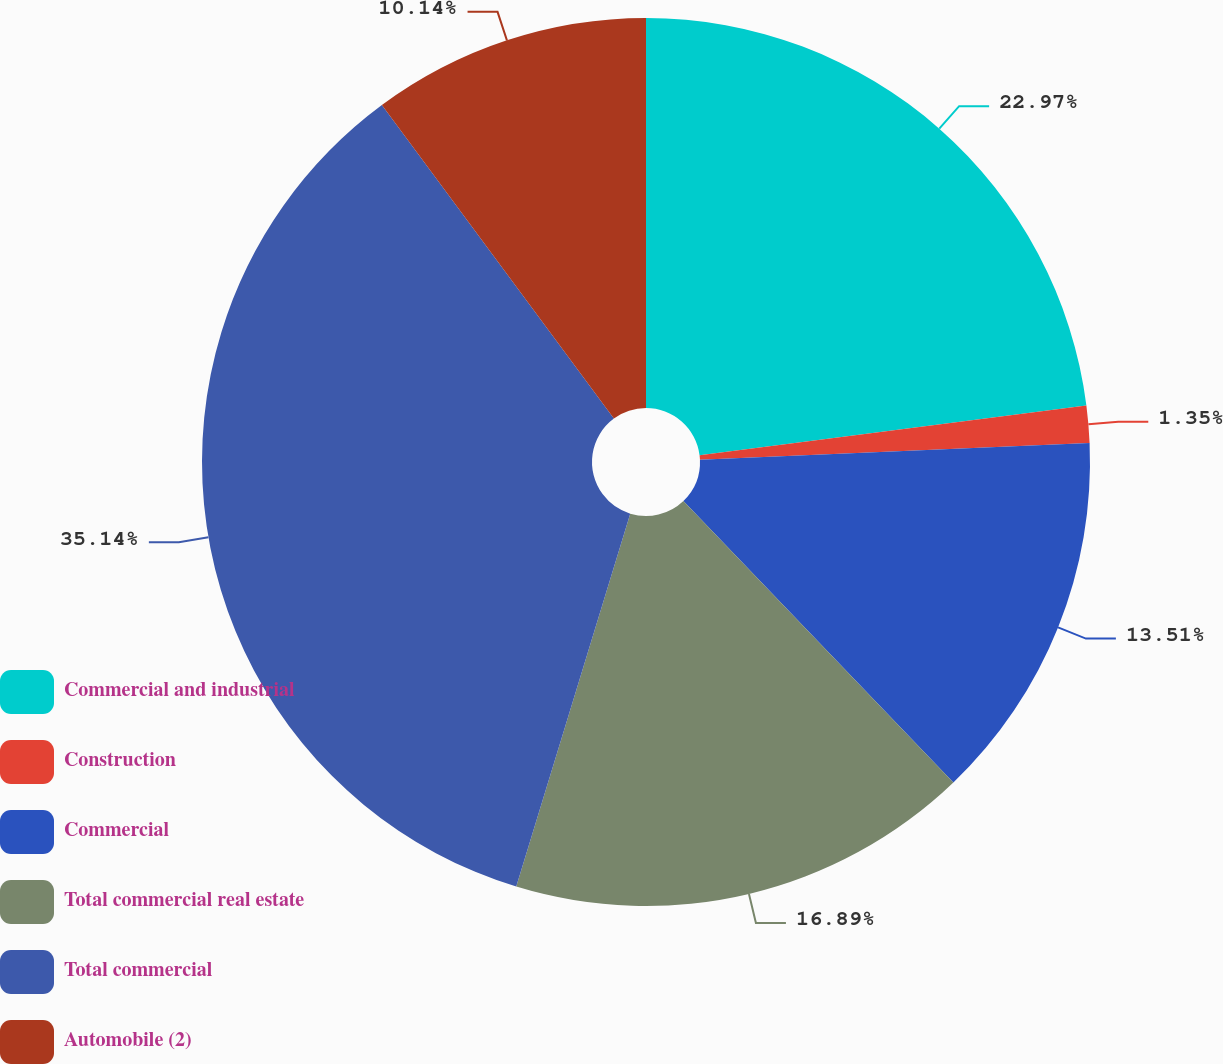Convert chart. <chart><loc_0><loc_0><loc_500><loc_500><pie_chart><fcel>Commercial and industrial<fcel>Construction<fcel>Commercial<fcel>Total commercial real estate<fcel>Total commercial<fcel>Automobile (2)<nl><fcel>22.97%<fcel>1.35%<fcel>13.51%<fcel>16.89%<fcel>35.14%<fcel>10.14%<nl></chart> 